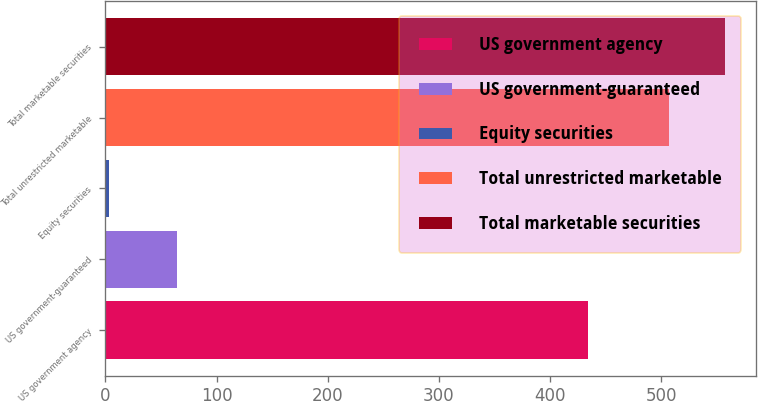Convert chart. <chart><loc_0><loc_0><loc_500><loc_500><bar_chart><fcel>US government agency<fcel>US government-guaranteed<fcel>Equity securities<fcel>Total unrestricted marketable<fcel>Total marketable securities<nl><fcel>434.4<fcel>64<fcel>3.6<fcel>506.8<fcel>557.83<nl></chart> 